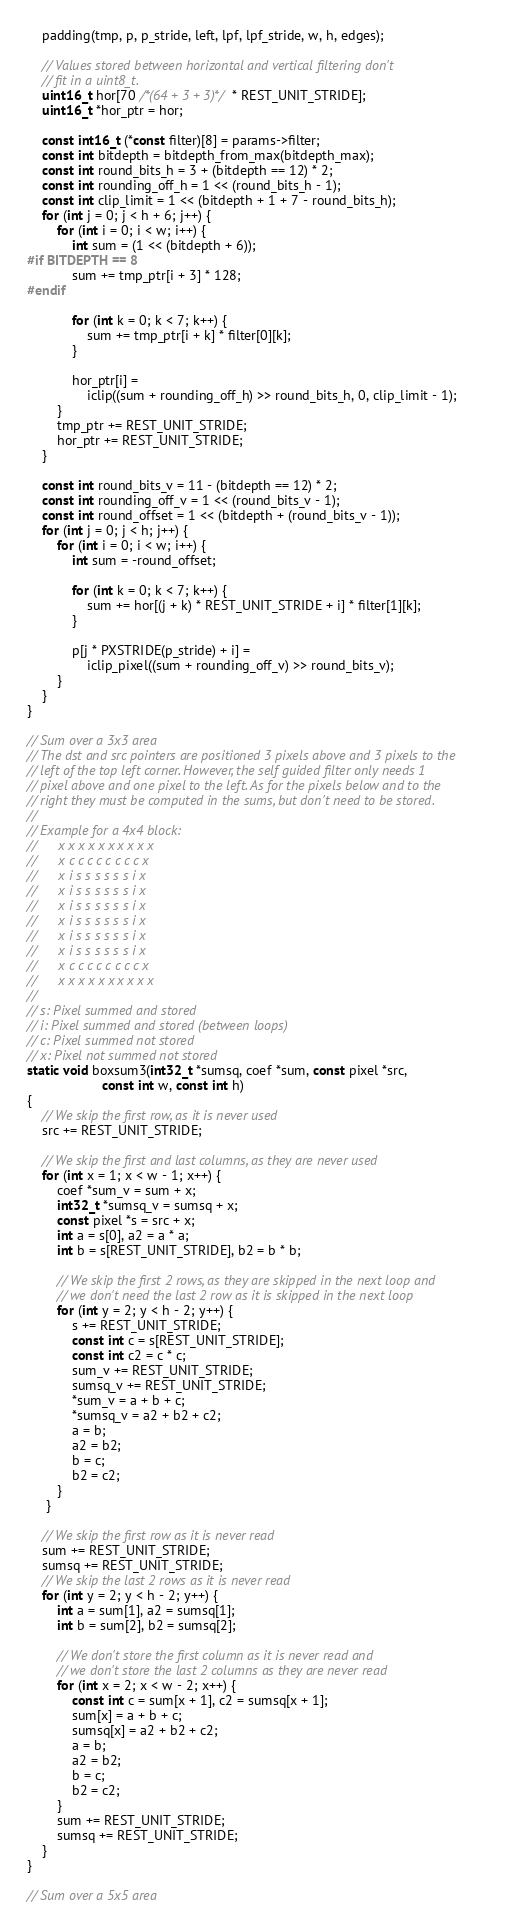<code> <loc_0><loc_0><loc_500><loc_500><_C_>    padding(tmp, p, p_stride, left, lpf, lpf_stride, w, h, edges);

    // Values stored between horizontal and vertical filtering don't
    // fit in a uint8_t.
    uint16_t hor[70 /*(64 + 3 + 3)*/ * REST_UNIT_STRIDE];
    uint16_t *hor_ptr = hor;

    const int16_t (*const filter)[8] = params->filter;
    const int bitdepth = bitdepth_from_max(bitdepth_max);
    const int round_bits_h = 3 + (bitdepth == 12) * 2;
    const int rounding_off_h = 1 << (round_bits_h - 1);
    const int clip_limit = 1 << (bitdepth + 1 + 7 - round_bits_h);
    for (int j = 0; j < h + 6; j++) {
        for (int i = 0; i < w; i++) {
            int sum = (1 << (bitdepth + 6));
#if BITDEPTH == 8
            sum += tmp_ptr[i + 3] * 128;
#endif

            for (int k = 0; k < 7; k++) {
                sum += tmp_ptr[i + k] * filter[0][k];
            }

            hor_ptr[i] =
                iclip((sum + rounding_off_h) >> round_bits_h, 0, clip_limit - 1);
        }
        tmp_ptr += REST_UNIT_STRIDE;
        hor_ptr += REST_UNIT_STRIDE;
    }

    const int round_bits_v = 11 - (bitdepth == 12) * 2;
    const int rounding_off_v = 1 << (round_bits_v - 1);
    const int round_offset = 1 << (bitdepth + (round_bits_v - 1));
    for (int j = 0; j < h; j++) {
        for (int i = 0; i < w; i++) {
            int sum = -round_offset;

            for (int k = 0; k < 7; k++) {
                sum += hor[(j + k) * REST_UNIT_STRIDE + i] * filter[1][k];
            }

            p[j * PXSTRIDE(p_stride) + i] =
                iclip_pixel((sum + rounding_off_v) >> round_bits_v);
        }
    }
}

// Sum over a 3x3 area
// The dst and src pointers are positioned 3 pixels above and 3 pixels to the
// left of the top left corner. However, the self guided filter only needs 1
// pixel above and one pixel to the left. As for the pixels below and to the
// right they must be computed in the sums, but don't need to be stored.
//
// Example for a 4x4 block:
//      x x x x x x x x x x
//      x c c c c c c c c x
//      x i s s s s s s i x
//      x i s s s s s s i x
//      x i s s s s s s i x
//      x i s s s s s s i x
//      x i s s s s s s i x
//      x i s s s s s s i x
//      x c c c c c c c c x
//      x x x x x x x x x x
//
// s: Pixel summed and stored
// i: Pixel summed and stored (between loops)
// c: Pixel summed not stored
// x: Pixel not summed not stored
static void boxsum3(int32_t *sumsq, coef *sum, const pixel *src,
                    const int w, const int h)
{
    // We skip the first row, as it is never used
    src += REST_UNIT_STRIDE;

    // We skip the first and last columns, as they are never used
    for (int x = 1; x < w - 1; x++) {
        coef *sum_v = sum + x;
        int32_t *sumsq_v = sumsq + x;
        const pixel *s = src + x;
        int a = s[0], a2 = a * a;
        int b = s[REST_UNIT_STRIDE], b2 = b * b;

        // We skip the first 2 rows, as they are skipped in the next loop and
        // we don't need the last 2 row as it is skipped in the next loop
        for (int y = 2; y < h - 2; y++) {
            s += REST_UNIT_STRIDE;
            const int c = s[REST_UNIT_STRIDE];
            const int c2 = c * c;
            sum_v += REST_UNIT_STRIDE;
            sumsq_v += REST_UNIT_STRIDE;
            *sum_v = a + b + c;
            *sumsq_v = a2 + b2 + c2;
            a = b;
            a2 = b2;
            b = c;
            b2 = c2;
        }
     }

    // We skip the first row as it is never read
    sum += REST_UNIT_STRIDE;
    sumsq += REST_UNIT_STRIDE;
    // We skip the last 2 rows as it is never read
    for (int y = 2; y < h - 2; y++) {
        int a = sum[1], a2 = sumsq[1];
        int b = sum[2], b2 = sumsq[2];

        // We don't store the first column as it is never read and
        // we don't store the last 2 columns as they are never read
        for (int x = 2; x < w - 2; x++) {
            const int c = sum[x + 1], c2 = sumsq[x + 1];
            sum[x] = a + b + c;
            sumsq[x] = a2 + b2 + c2;
            a = b;
            a2 = b2;
            b = c;
            b2 = c2;
        }
        sum += REST_UNIT_STRIDE;
        sumsq += REST_UNIT_STRIDE;
    }
}

// Sum over a 5x5 area</code> 